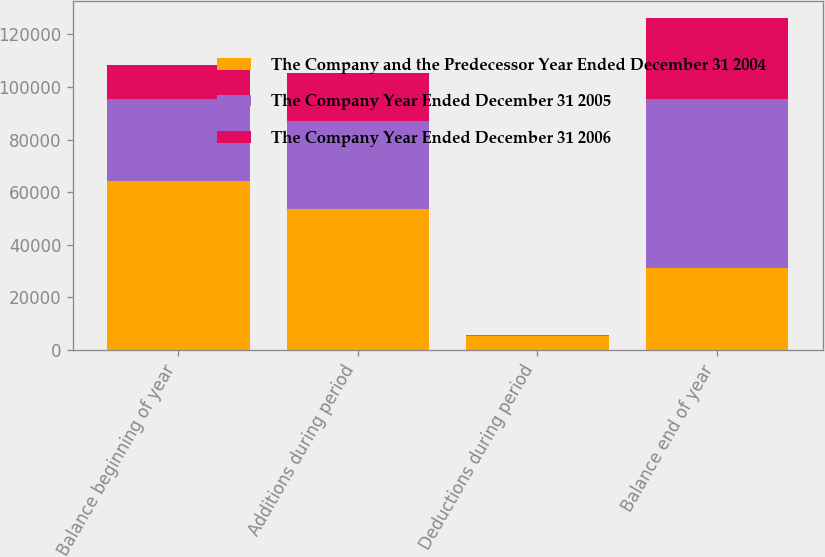Convert chart to OTSL. <chart><loc_0><loc_0><loc_500><loc_500><stacked_bar_chart><ecel><fcel>Balance beginning of year<fcel>Additions during period<fcel>Deductions during period<fcel>Balance end of year<nl><fcel>The Company and the Predecessor Year Ended December 31 2004<fcel>64404<fcel>53478<fcel>5403<fcel>30980<nl><fcel>The Company Year Ended December 31 2005<fcel>30980<fcel>33626<fcel>202<fcel>64404<nl><fcel>The Company Year Ended December 31 2006<fcel>13026<fcel>18207<fcel>253<fcel>30980<nl></chart> 